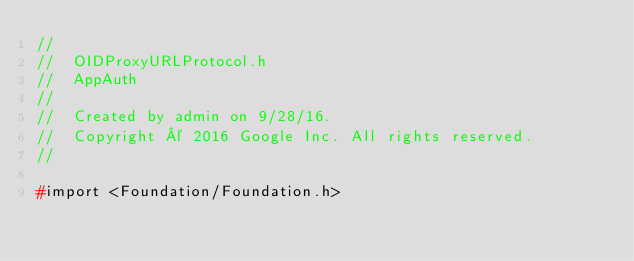Convert code to text. <code><loc_0><loc_0><loc_500><loc_500><_C_>//
//  OIDProxyURLProtocol.h
//  AppAuth
//
//  Created by admin on 9/28/16.
//  Copyright © 2016 Google Inc. All rights reserved.
//

#import <Foundation/Foundation.h>
</code> 